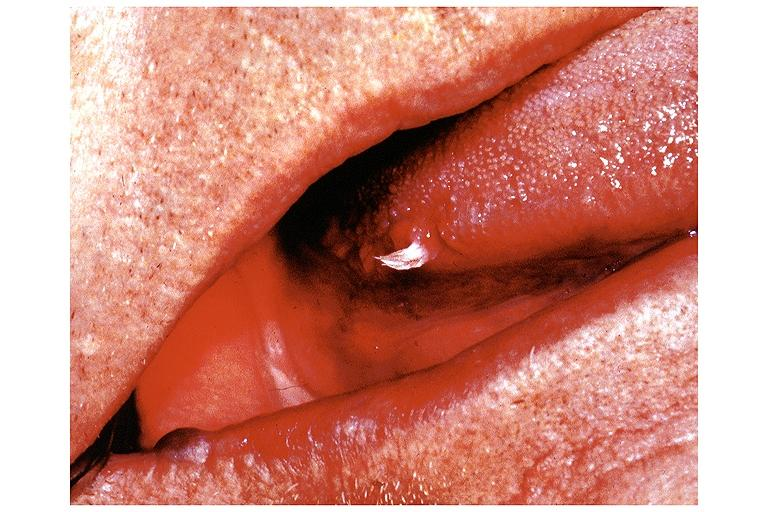does this image show papilloma?
Answer the question using a single word or phrase. Yes 